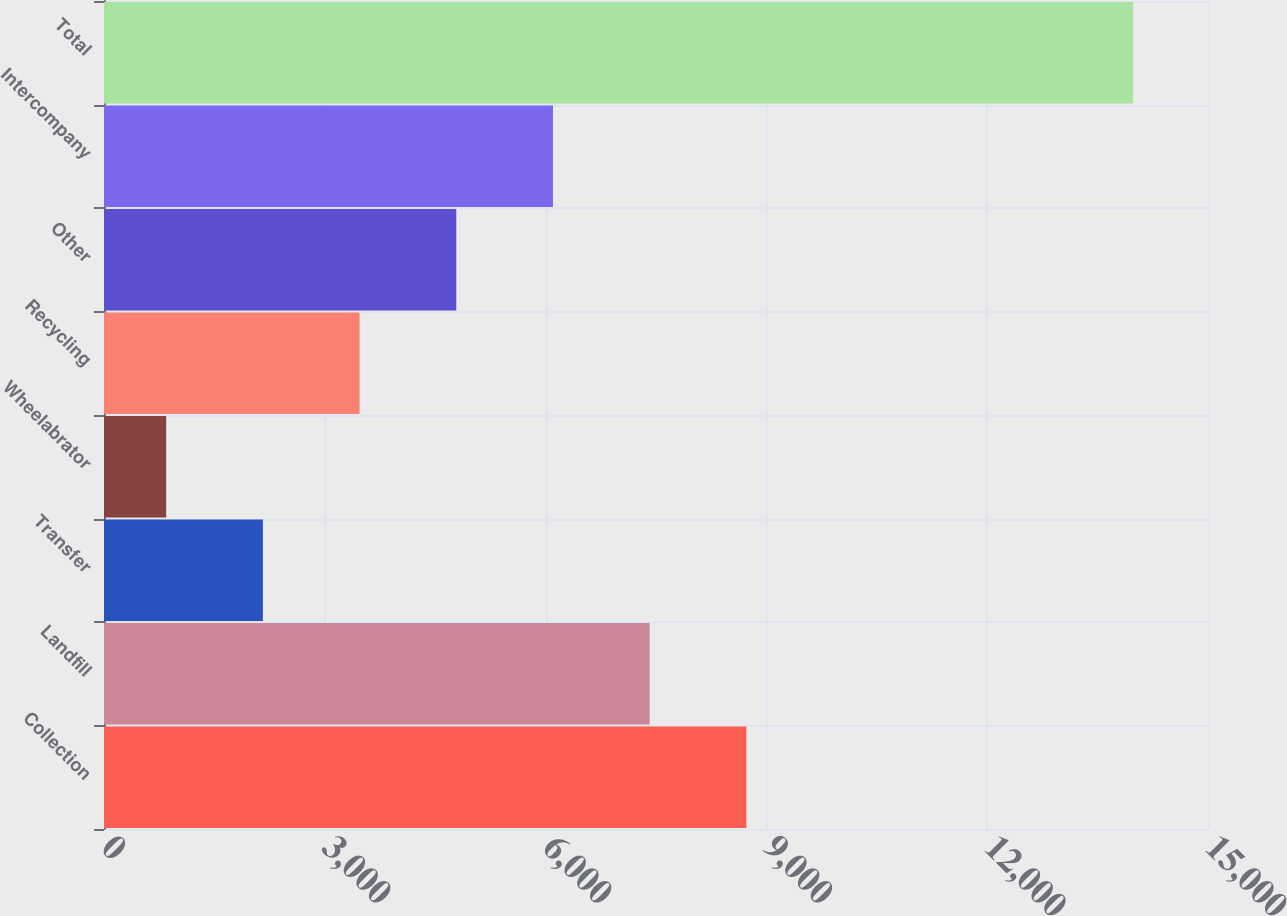Convert chart. <chart><loc_0><loc_0><loc_500><loc_500><bar_chart><fcel>Collection<fcel>Landfill<fcel>Transfer<fcel>Wheelabrator<fcel>Recycling<fcel>Other<fcel>Intercompany<fcel>Total<nl><fcel>8727.8<fcel>7414<fcel>2158.8<fcel>845<fcel>3472.6<fcel>4786.4<fcel>6100.2<fcel>13983<nl></chart> 